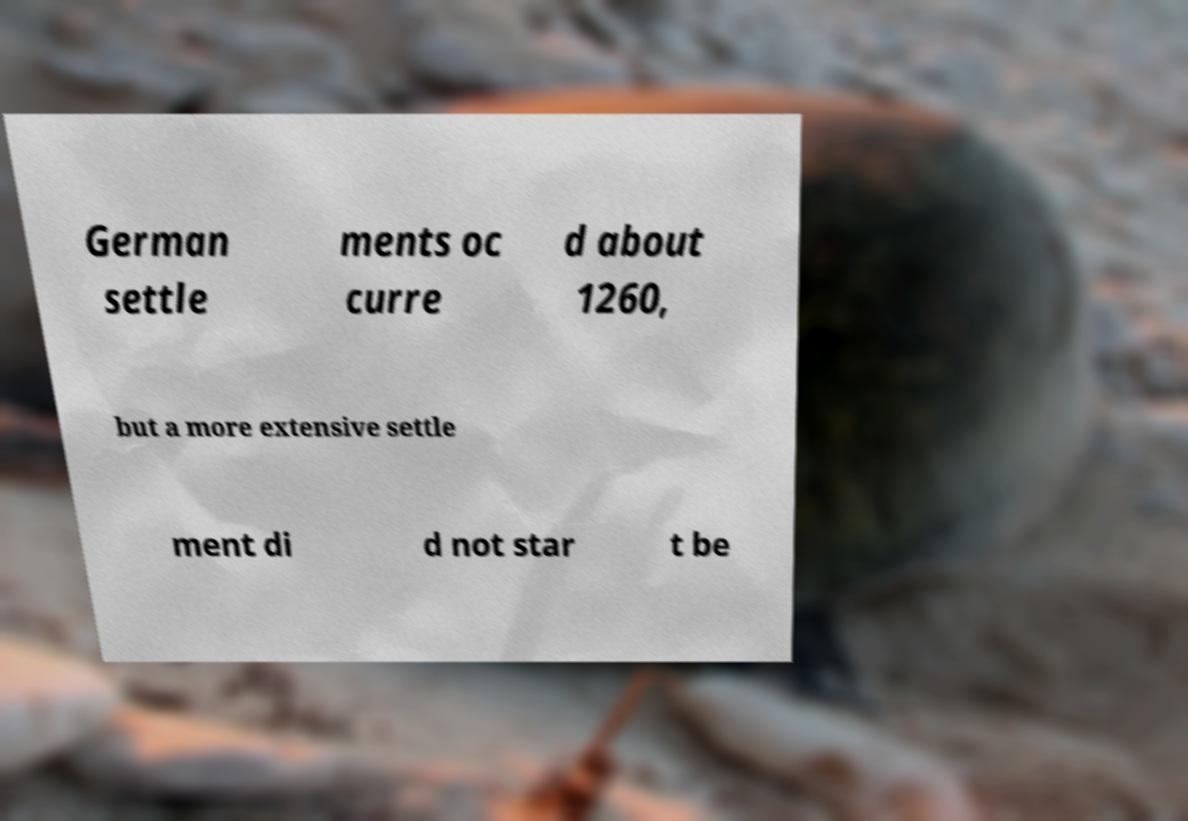Could you extract and type out the text from this image? German settle ments oc curre d about 1260, but a more extensive settle ment di d not star t be 